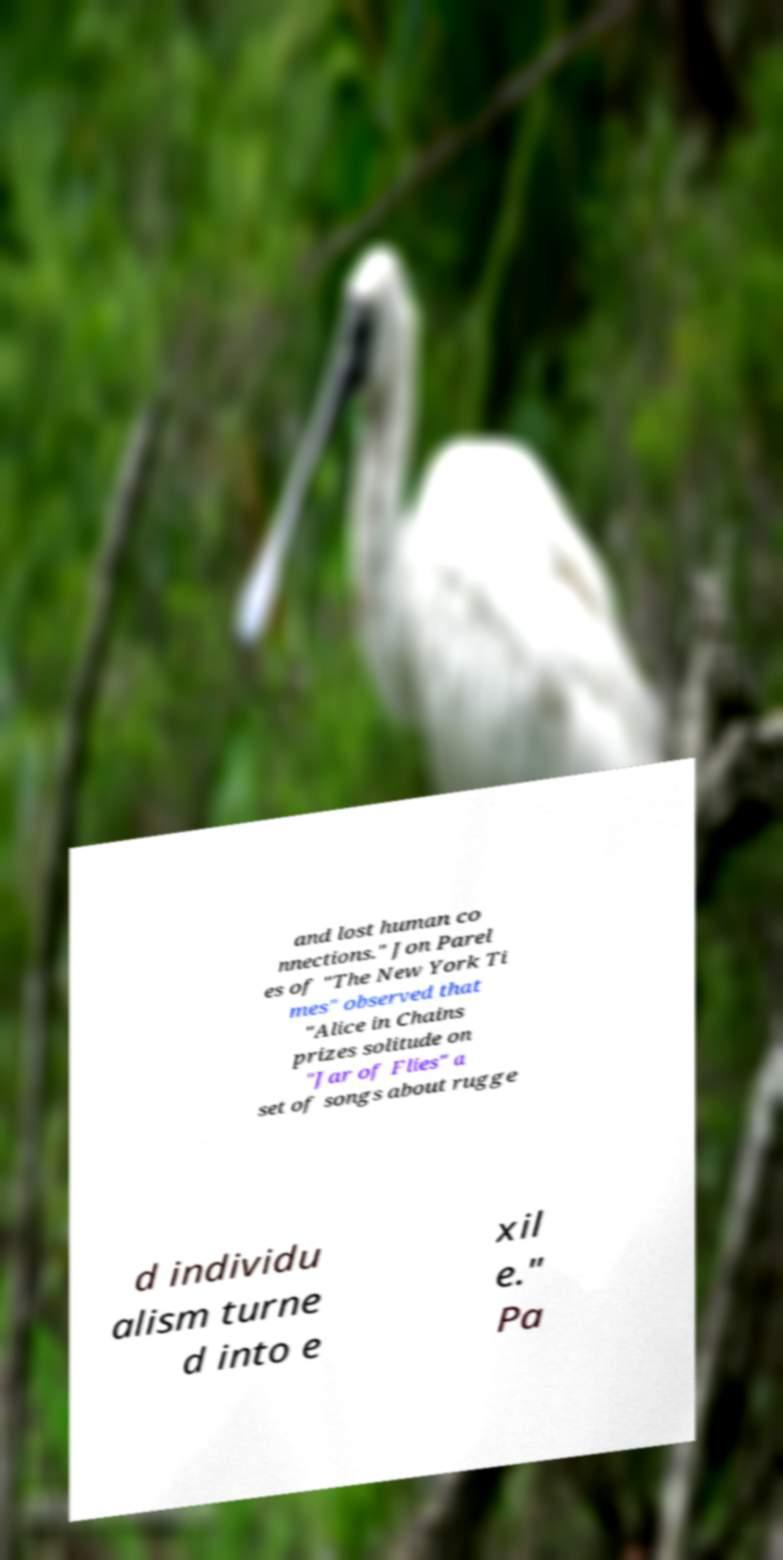For documentation purposes, I need the text within this image transcribed. Could you provide that? and lost human co nnections." Jon Parel es of "The New York Ti mes" observed that "Alice in Chains prizes solitude on "Jar of Flies" a set of songs about rugge d individu alism turne d into e xil e." Pa 